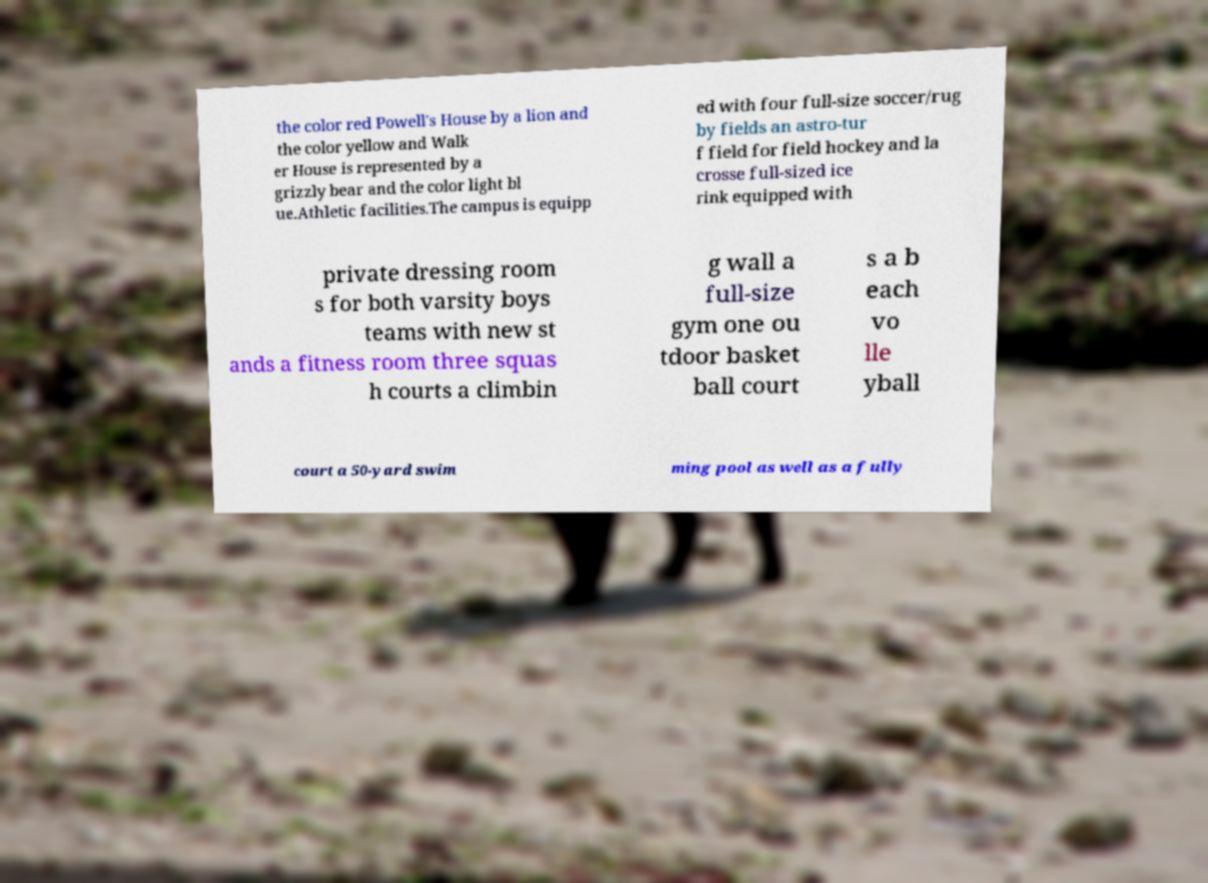Could you assist in decoding the text presented in this image and type it out clearly? the color red Powell's House by a lion and the color yellow and Walk er House is represented by a grizzly bear and the color light bl ue.Athletic facilities.The campus is equipp ed with four full-size soccer/rug by fields an astro-tur f field for field hockey and la crosse full-sized ice rink equipped with private dressing room s for both varsity boys teams with new st ands a fitness room three squas h courts a climbin g wall a full-size gym one ou tdoor basket ball court s a b each vo lle yball court a 50-yard swim ming pool as well as a fully 